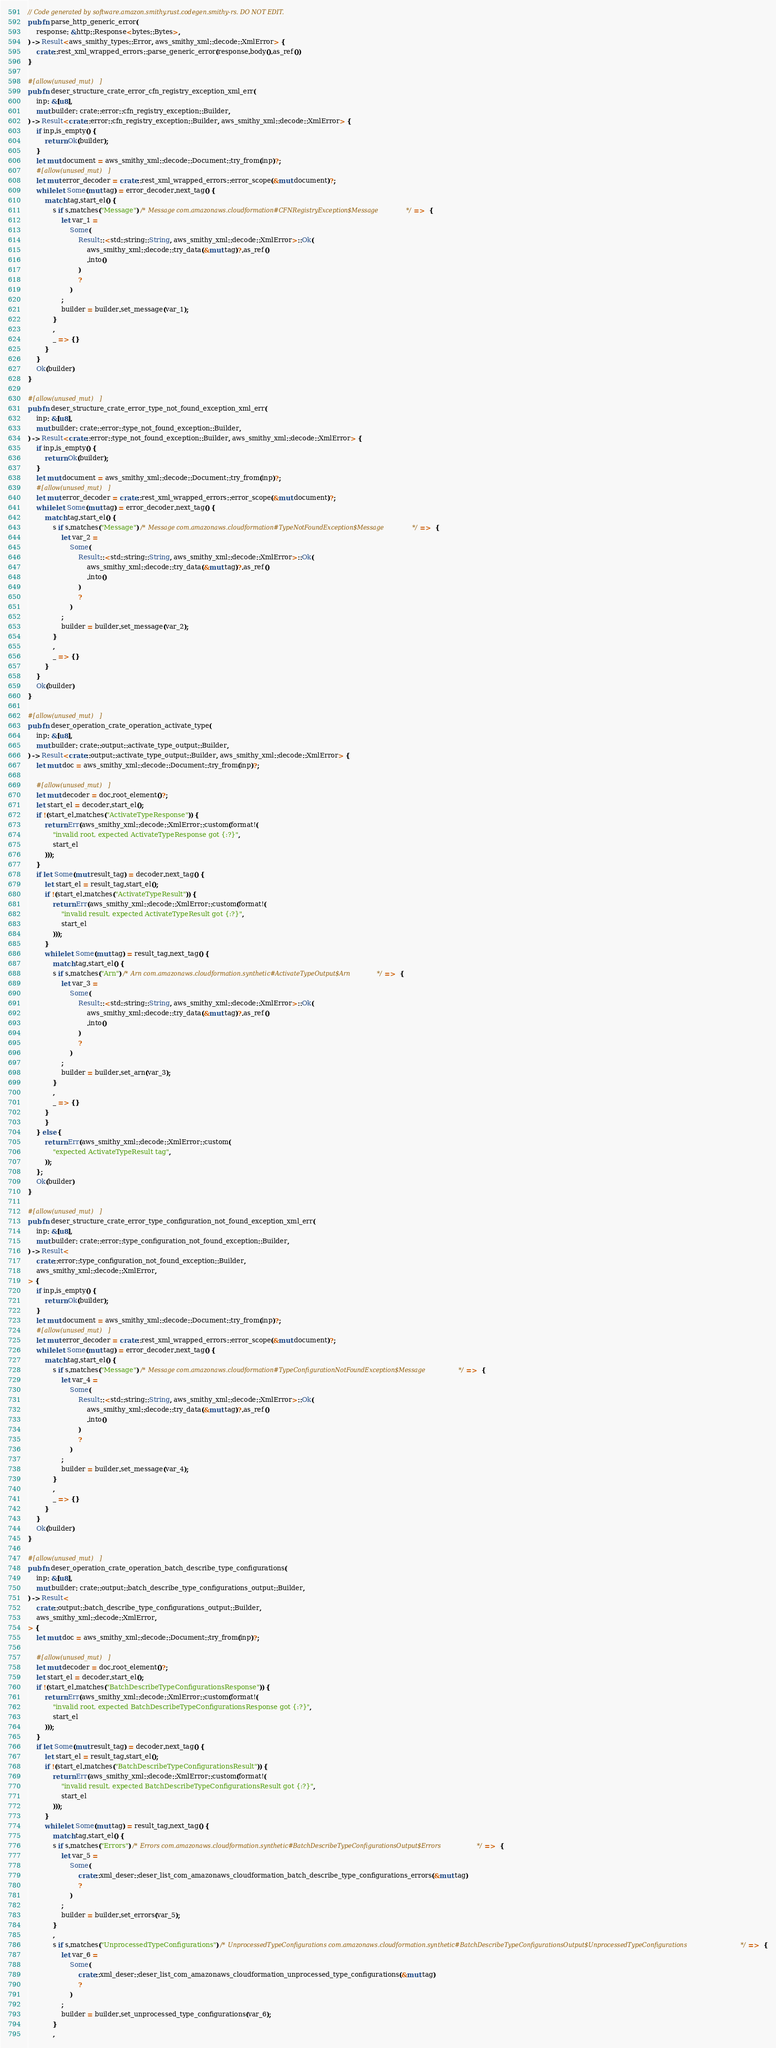<code> <loc_0><loc_0><loc_500><loc_500><_Rust_>// Code generated by software.amazon.smithy.rust.codegen.smithy-rs. DO NOT EDIT.
pub fn parse_http_generic_error(
    response: &http::Response<bytes::Bytes>,
) -> Result<aws_smithy_types::Error, aws_smithy_xml::decode::XmlError> {
    crate::rest_xml_wrapped_errors::parse_generic_error(response.body().as_ref())
}

#[allow(unused_mut)]
pub fn deser_structure_crate_error_cfn_registry_exception_xml_err(
    inp: &[u8],
    mut builder: crate::error::cfn_registry_exception::Builder,
) -> Result<crate::error::cfn_registry_exception::Builder, aws_smithy_xml::decode::XmlError> {
    if inp.is_empty() {
        return Ok(builder);
    }
    let mut document = aws_smithy_xml::decode::Document::try_from(inp)?;
    #[allow(unused_mut)]
    let mut error_decoder = crate::rest_xml_wrapped_errors::error_scope(&mut document)?;
    while let Some(mut tag) = error_decoder.next_tag() {
        match tag.start_el() {
            s if s.matches("Message") /* Message com.amazonaws.cloudformation#CFNRegistryException$Message */ =>  {
                let var_1 =
                    Some(
                        Result::<std::string::String, aws_smithy_xml::decode::XmlError>::Ok(
                            aws_smithy_xml::decode::try_data(&mut tag)?.as_ref()
                            .into()
                        )
                        ?
                    )
                ;
                builder = builder.set_message(var_1);
            }
            ,
            _ => {}
        }
    }
    Ok(builder)
}

#[allow(unused_mut)]
pub fn deser_structure_crate_error_type_not_found_exception_xml_err(
    inp: &[u8],
    mut builder: crate::error::type_not_found_exception::Builder,
) -> Result<crate::error::type_not_found_exception::Builder, aws_smithy_xml::decode::XmlError> {
    if inp.is_empty() {
        return Ok(builder);
    }
    let mut document = aws_smithy_xml::decode::Document::try_from(inp)?;
    #[allow(unused_mut)]
    let mut error_decoder = crate::rest_xml_wrapped_errors::error_scope(&mut document)?;
    while let Some(mut tag) = error_decoder.next_tag() {
        match tag.start_el() {
            s if s.matches("Message") /* Message com.amazonaws.cloudformation#TypeNotFoundException$Message */ =>  {
                let var_2 =
                    Some(
                        Result::<std::string::String, aws_smithy_xml::decode::XmlError>::Ok(
                            aws_smithy_xml::decode::try_data(&mut tag)?.as_ref()
                            .into()
                        )
                        ?
                    )
                ;
                builder = builder.set_message(var_2);
            }
            ,
            _ => {}
        }
    }
    Ok(builder)
}

#[allow(unused_mut)]
pub fn deser_operation_crate_operation_activate_type(
    inp: &[u8],
    mut builder: crate::output::activate_type_output::Builder,
) -> Result<crate::output::activate_type_output::Builder, aws_smithy_xml::decode::XmlError> {
    let mut doc = aws_smithy_xml::decode::Document::try_from(inp)?;

    #[allow(unused_mut)]
    let mut decoder = doc.root_element()?;
    let start_el = decoder.start_el();
    if !(start_el.matches("ActivateTypeResponse")) {
        return Err(aws_smithy_xml::decode::XmlError::custom(format!(
            "invalid root, expected ActivateTypeResponse got {:?}",
            start_el
        )));
    }
    if let Some(mut result_tag) = decoder.next_tag() {
        let start_el = result_tag.start_el();
        if !(start_el.matches("ActivateTypeResult")) {
            return Err(aws_smithy_xml::decode::XmlError::custom(format!(
                "invalid result, expected ActivateTypeResult got {:?}",
                start_el
            )));
        }
        while let Some(mut tag) = result_tag.next_tag() {
            match tag.start_el() {
            s if s.matches("Arn") /* Arn com.amazonaws.cloudformation.synthetic#ActivateTypeOutput$Arn */ =>  {
                let var_3 =
                    Some(
                        Result::<std::string::String, aws_smithy_xml::decode::XmlError>::Ok(
                            aws_smithy_xml::decode::try_data(&mut tag)?.as_ref()
                            .into()
                        )
                        ?
                    )
                ;
                builder = builder.set_arn(var_3);
            }
            ,
            _ => {}
        }
        }
    } else {
        return Err(aws_smithy_xml::decode::XmlError::custom(
            "expected ActivateTypeResult tag",
        ));
    };
    Ok(builder)
}

#[allow(unused_mut)]
pub fn deser_structure_crate_error_type_configuration_not_found_exception_xml_err(
    inp: &[u8],
    mut builder: crate::error::type_configuration_not_found_exception::Builder,
) -> Result<
    crate::error::type_configuration_not_found_exception::Builder,
    aws_smithy_xml::decode::XmlError,
> {
    if inp.is_empty() {
        return Ok(builder);
    }
    let mut document = aws_smithy_xml::decode::Document::try_from(inp)?;
    #[allow(unused_mut)]
    let mut error_decoder = crate::rest_xml_wrapped_errors::error_scope(&mut document)?;
    while let Some(mut tag) = error_decoder.next_tag() {
        match tag.start_el() {
            s if s.matches("Message") /* Message com.amazonaws.cloudformation#TypeConfigurationNotFoundException$Message */ =>  {
                let var_4 =
                    Some(
                        Result::<std::string::String, aws_smithy_xml::decode::XmlError>::Ok(
                            aws_smithy_xml::decode::try_data(&mut tag)?.as_ref()
                            .into()
                        )
                        ?
                    )
                ;
                builder = builder.set_message(var_4);
            }
            ,
            _ => {}
        }
    }
    Ok(builder)
}

#[allow(unused_mut)]
pub fn deser_operation_crate_operation_batch_describe_type_configurations(
    inp: &[u8],
    mut builder: crate::output::batch_describe_type_configurations_output::Builder,
) -> Result<
    crate::output::batch_describe_type_configurations_output::Builder,
    aws_smithy_xml::decode::XmlError,
> {
    let mut doc = aws_smithy_xml::decode::Document::try_from(inp)?;

    #[allow(unused_mut)]
    let mut decoder = doc.root_element()?;
    let start_el = decoder.start_el();
    if !(start_el.matches("BatchDescribeTypeConfigurationsResponse")) {
        return Err(aws_smithy_xml::decode::XmlError::custom(format!(
            "invalid root, expected BatchDescribeTypeConfigurationsResponse got {:?}",
            start_el
        )));
    }
    if let Some(mut result_tag) = decoder.next_tag() {
        let start_el = result_tag.start_el();
        if !(start_el.matches("BatchDescribeTypeConfigurationsResult")) {
            return Err(aws_smithy_xml::decode::XmlError::custom(format!(
                "invalid result, expected BatchDescribeTypeConfigurationsResult got {:?}",
                start_el
            )));
        }
        while let Some(mut tag) = result_tag.next_tag() {
            match tag.start_el() {
            s if s.matches("Errors") /* Errors com.amazonaws.cloudformation.synthetic#BatchDescribeTypeConfigurationsOutput$Errors */ =>  {
                let var_5 =
                    Some(
                        crate::xml_deser::deser_list_com_amazonaws_cloudformation_batch_describe_type_configurations_errors(&mut tag)
                        ?
                    )
                ;
                builder = builder.set_errors(var_5);
            }
            ,
            s if s.matches("UnprocessedTypeConfigurations") /* UnprocessedTypeConfigurations com.amazonaws.cloudformation.synthetic#BatchDescribeTypeConfigurationsOutput$UnprocessedTypeConfigurations */ =>  {
                let var_6 =
                    Some(
                        crate::xml_deser::deser_list_com_amazonaws_cloudformation_unprocessed_type_configurations(&mut tag)
                        ?
                    )
                ;
                builder = builder.set_unprocessed_type_configurations(var_6);
            }
            ,</code> 